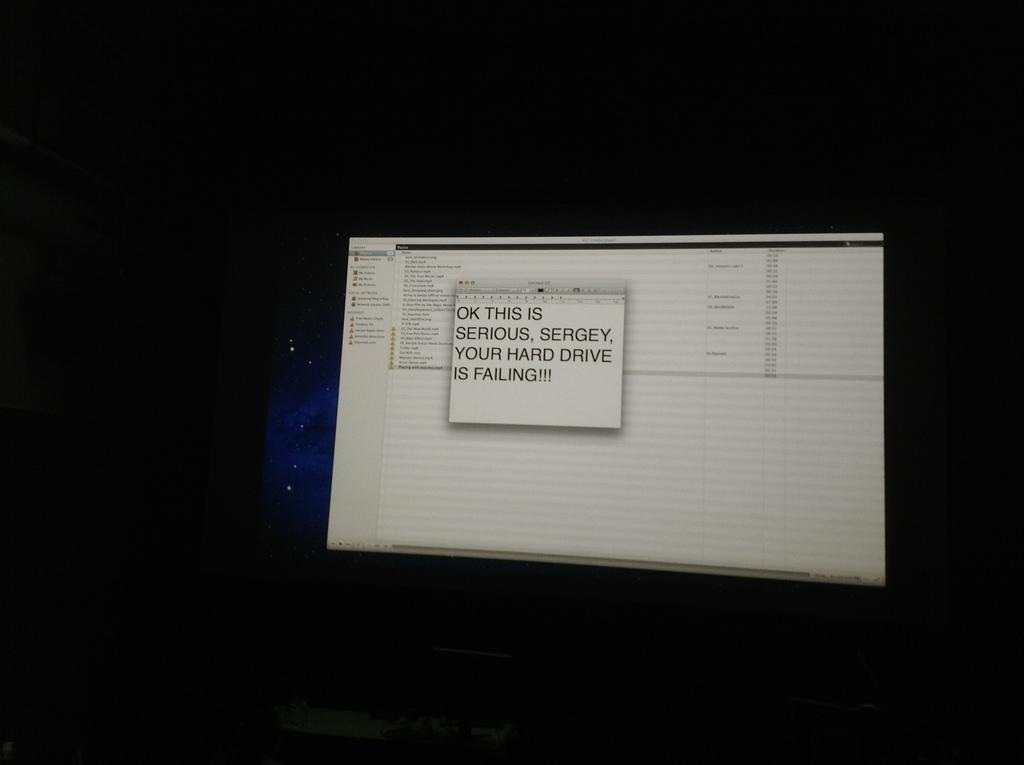<image>
Write a terse but informative summary of the picture. A pop up message that someone's hard drive is failing. 